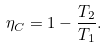<formula> <loc_0><loc_0><loc_500><loc_500>\eta _ { C } = 1 - \frac { T _ { 2 } } { T _ { 1 } } .</formula> 